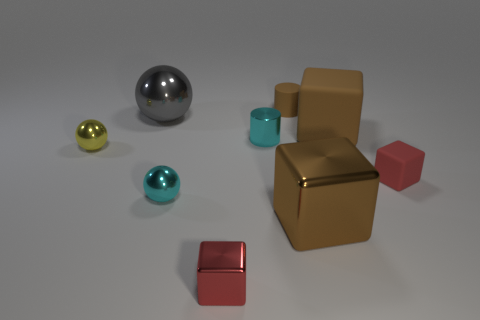Is there a cyan thing of the same size as the gray metallic sphere?
Offer a terse response. No. Is the color of the large block in front of the red matte object the same as the shiny cylinder?
Offer a very short reply. No. There is a small shiny thing that is both in front of the yellow metallic object and behind the tiny red metallic block; what color is it?
Offer a very short reply. Cyan. What is the shape of the red metal object that is the same size as the cyan shiny sphere?
Your response must be concise. Cube. Are there any other metallic things of the same shape as the red metal thing?
Offer a very short reply. Yes. Is the size of the rubber thing that is behind the gray metal object the same as the large shiny cube?
Provide a succinct answer. No. What size is the cube that is to the right of the small brown thing and in front of the tiny rubber cube?
Your answer should be very brief. Large. What number of other things are the same material as the small brown cylinder?
Give a very brief answer. 2. There is a sphere that is behind the tiny yellow metal thing; how big is it?
Provide a succinct answer. Large. Is the color of the tiny matte cube the same as the small rubber cylinder?
Provide a succinct answer. No. 